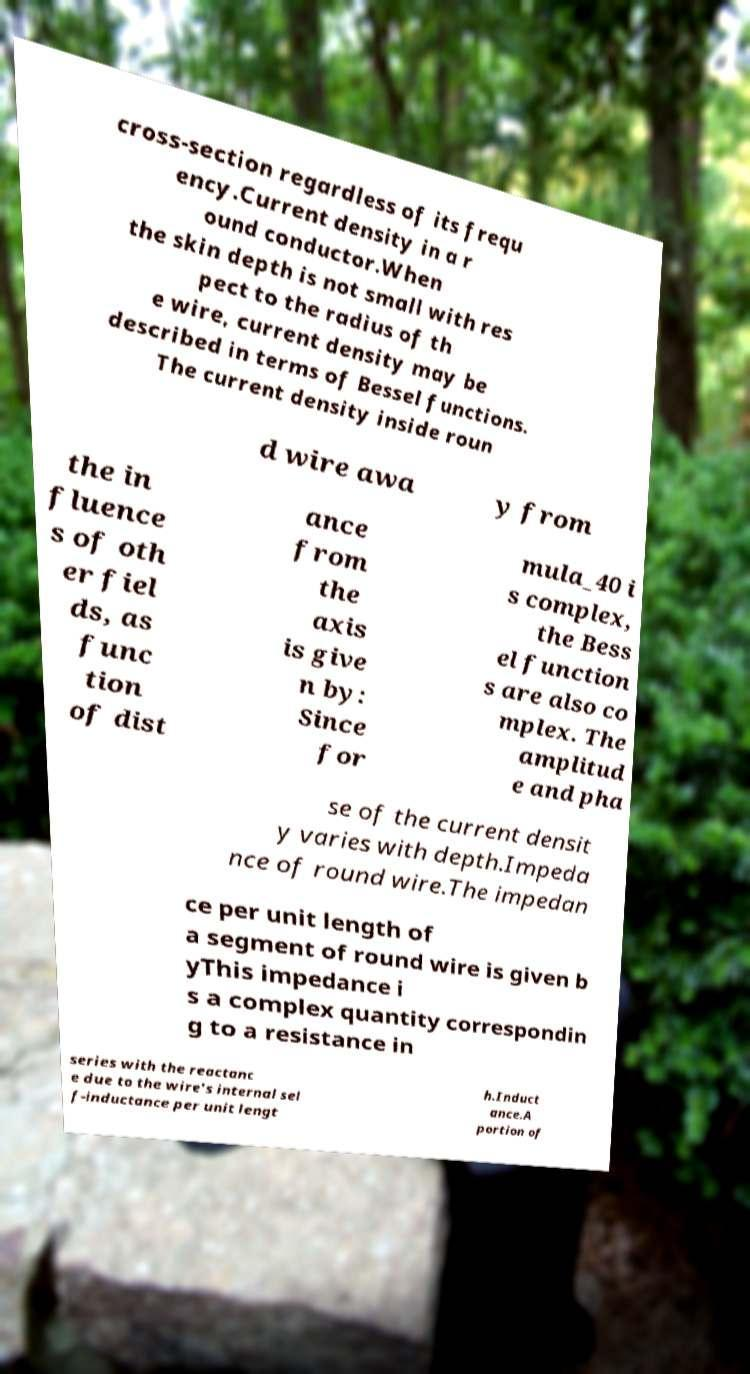Please read and relay the text visible in this image. What does it say? cross-section regardless of its frequ ency.Current density in a r ound conductor.When the skin depth is not small with res pect to the radius of th e wire, current density may be described in terms of Bessel functions. The current density inside roun d wire awa y from the in fluence s of oth er fiel ds, as func tion of dist ance from the axis is give n by: Since for mula_40 i s complex, the Bess el function s are also co mplex. The amplitud e and pha se of the current densit y varies with depth.Impeda nce of round wire.The impedan ce per unit length of a segment of round wire is given b yThis impedance i s a complex quantity correspondin g to a resistance in series with the reactanc e due to the wire's internal sel f-inductance per unit lengt h.Induct ance.A portion of 